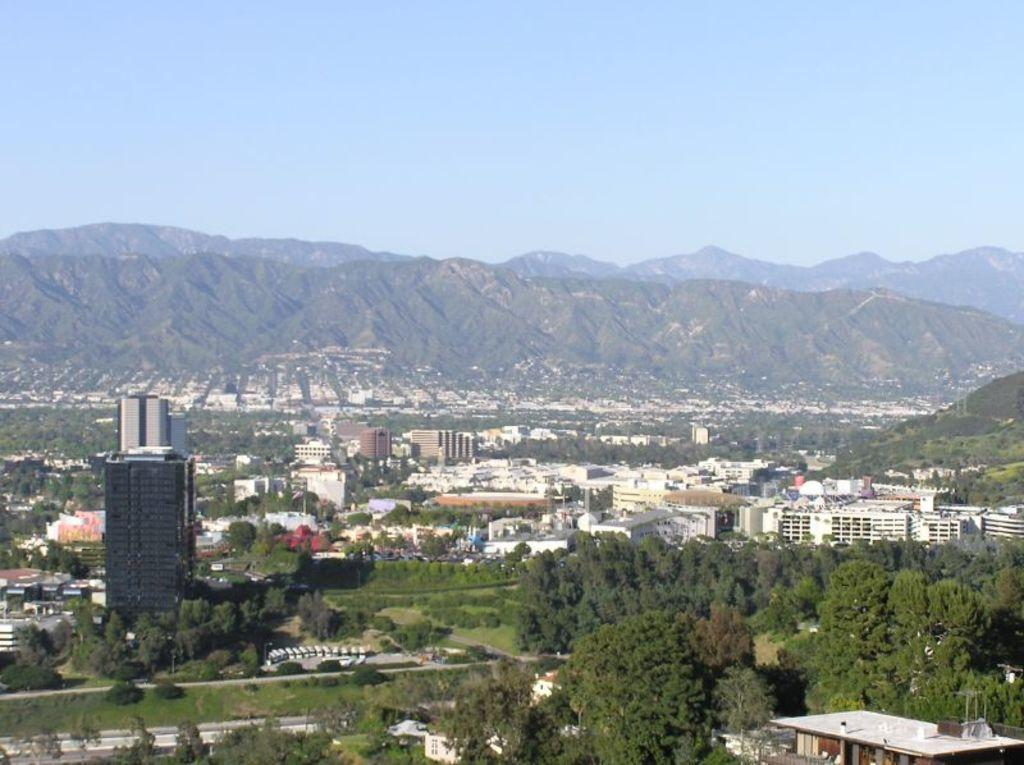What type of natural elements can be seen in the image? There are many trees in the image. What type of man-made structures are present in the image? There are buildings in the image. Can you describe the background of the image? There are trees and the sky visible in the background of the image. What type of appliance can be seen in the image? There is no appliance present in the image. What type of border surrounds the trees in the image? There is no border surrounding the trees in the image; they are situated in an open area. 